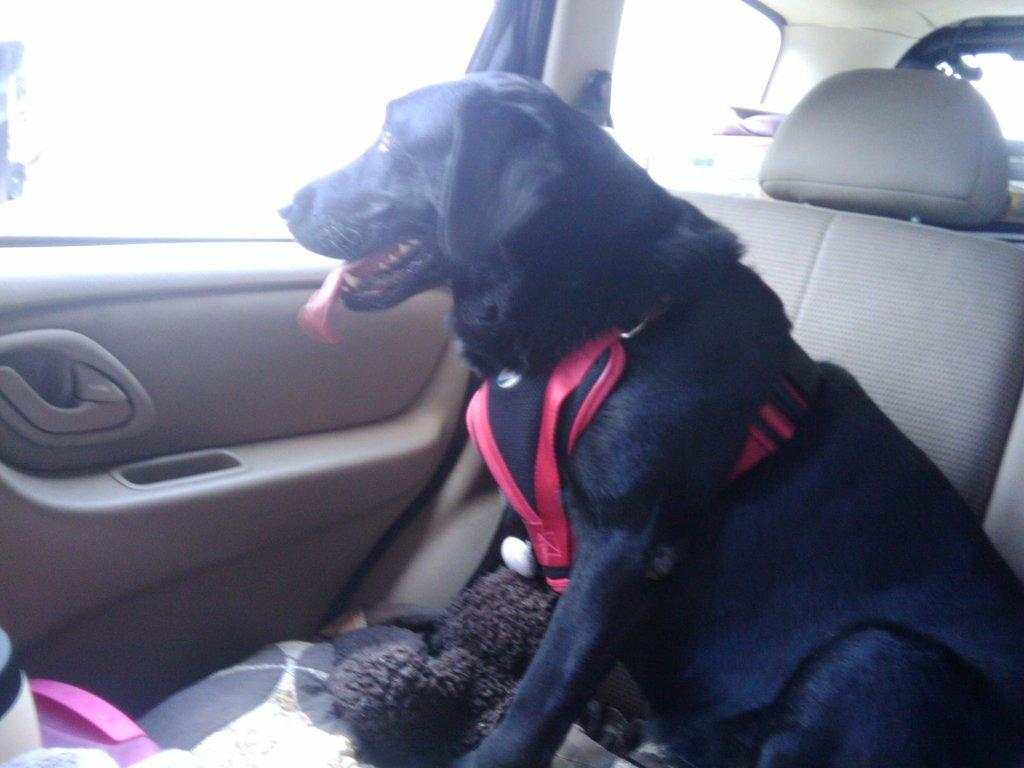What type of animal is in the image? There is a black dog in the image. Where is the dog located? The dog is sitting in a car. What is attached to the dog? A red belt is attached to the dog. What is the dog doing in the car? The dog is looking through a window. How many cats are sitting next to the dog in the car? There are no cats present in the image; it only features a black dog. What type of leather material is covering the seats in the car? The provided facts do not mention the material of the car seats, so it cannot be determined from the image. 